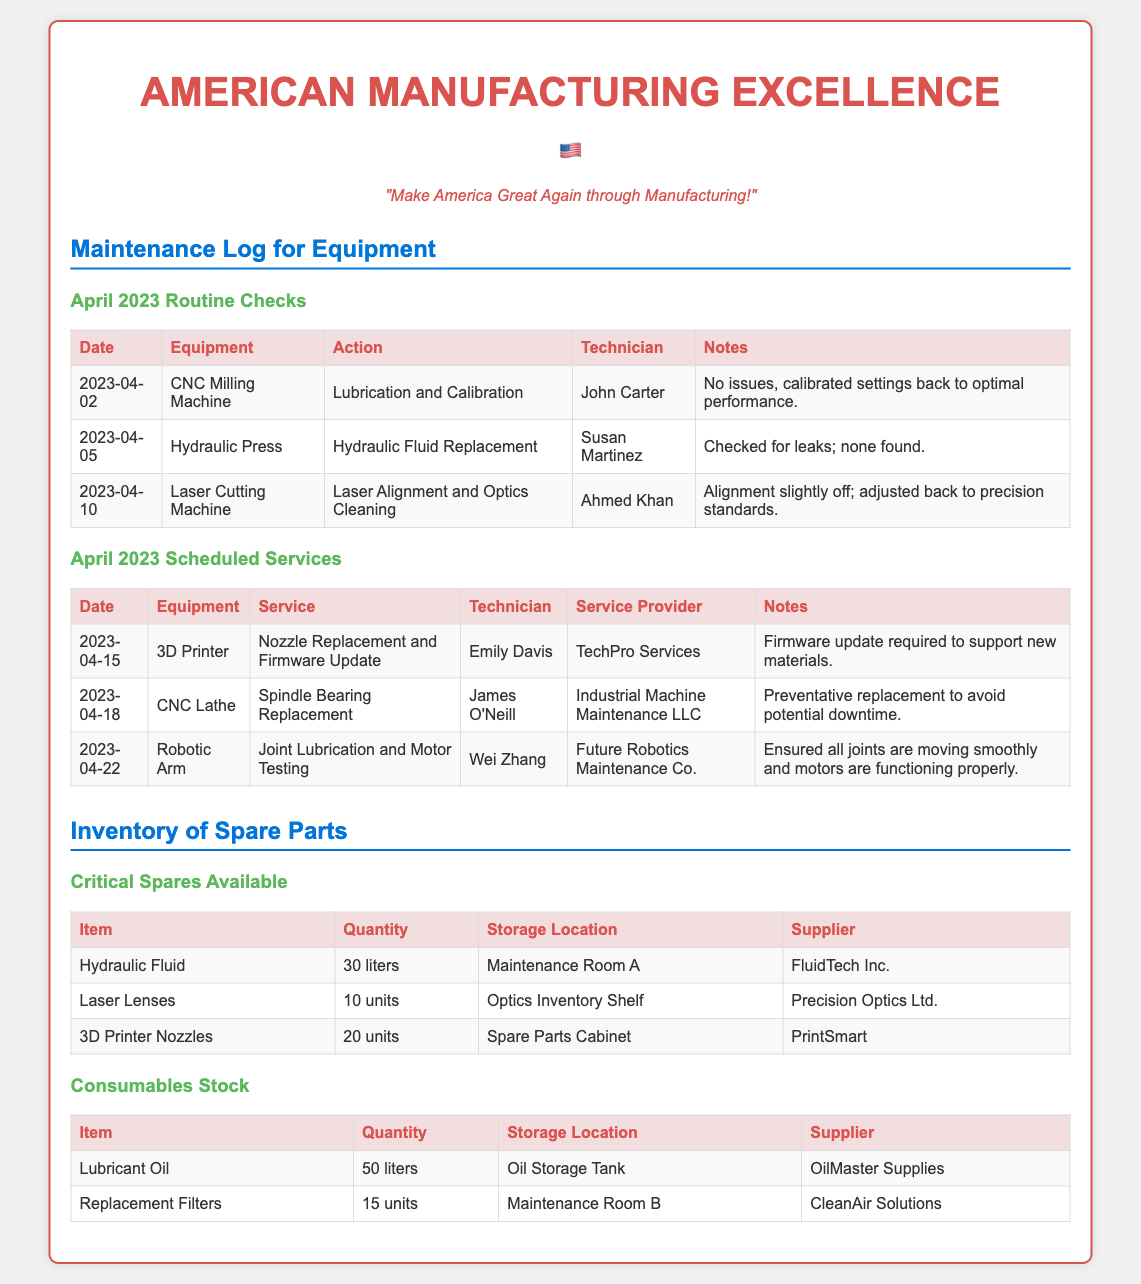What is the date for the Laser Cutting Machine service? The service for the Laser Cutting Machine was conducted on April 10, 2023.
Answer: April 10, 2023 Who performed the lubrication and calibration on April 2, 2023? The technician who performed the lubrication and calibration was John Carter.
Answer: John Carter What service is scheduled for April 15, 2023? The scheduled service for April 15, 2023, is Nozzle Replacement and Firmware Update.
Answer: Nozzle Replacement and Firmware Update How many liters of hydraulic fluid are available? The document states that there are 30 liters of hydraulic fluid available.
Answer: 30 liters Which equipment had the action of checking for leaks? The action of checking for leaks was conducted on the Hydraulic Press.
Answer: Hydraulic Press What is the supplier for the 3D Printer Nozzles? The supplier for the 3D Printer Nozzles is PrintSmart.
Answer: PrintSmart What is the purpose of the spindle bearing replacement scheduled for April 18, 2023? The spindle bearing replacement is a preventative measure to avoid potential downtime.
Answer: Preventative replacement Who is the service provider for the Robotic Arm maintenance on April 22, 2023? The service provider for the Robotic Arm maintenance is Future Robotics Maintenance Co.
Answer: Future Robotics Maintenance Co What action was taken on the Laser Cutting Machine? The action taken was Laser Alignment and Optics Cleaning.
Answer: Laser Alignment and Optics Cleaning 